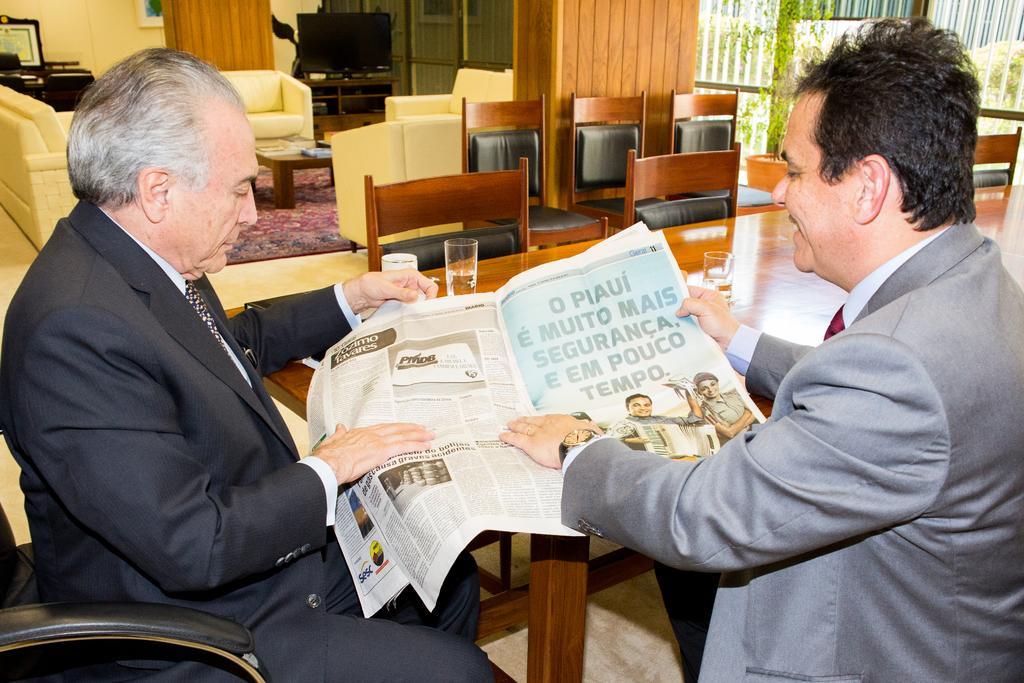Please provide a concise description of this image. In this image I see 2 men, in which one of them is smiling and I can also see that both of them are holding the paper. I see that there is a table in front and few glasses on it and lot of chairs over here. In the background I see the T. V , a sofa set and the wall. 